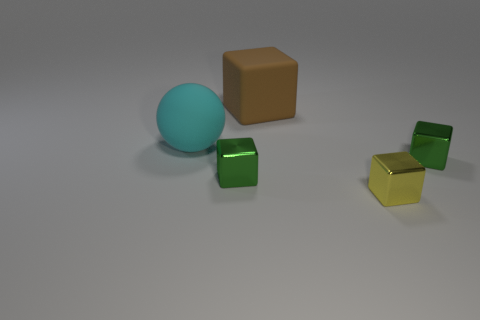Subtract all matte cubes. How many cubes are left? 3 Subtract 1 balls. How many balls are left? 0 Subtract all brown cubes. How many cubes are left? 3 Subtract all balls. How many objects are left? 4 Add 4 rubber blocks. How many objects exist? 9 Subtract all brown blocks. Subtract all green cylinders. How many blocks are left? 3 Subtract all purple blocks. How many gray balls are left? 0 Subtract all large blocks. Subtract all yellow shiny objects. How many objects are left? 3 Add 4 large things. How many large things are left? 6 Add 4 small green rubber cylinders. How many small green rubber cylinders exist? 4 